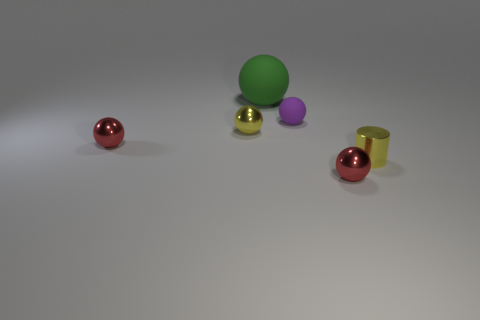Subtract 1 balls. How many balls are left? 4 Subtract all large green spheres. How many spheres are left? 4 Subtract all green spheres. How many spheres are left? 4 Subtract all yellow balls. Subtract all brown cylinders. How many balls are left? 4 Add 4 matte objects. How many objects exist? 10 Subtract 0 cyan blocks. How many objects are left? 6 Subtract all balls. How many objects are left? 1 Subtract all large blue metallic things. Subtract all red shiny spheres. How many objects are left? 4 Add 4 purple things. How many purple things are left? 5 Add 6 large green objects. How many large green objects exist? 7 